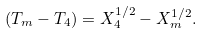Convert formula to latex. <formula><loc_0><loc_0><loc_500><loc_500>( T _ { m } - T _ { 4 } ) = X _ { 4 } ^ { 1 / 2 } - X _ { m } ^ { 1 / 2 } .</formula> 